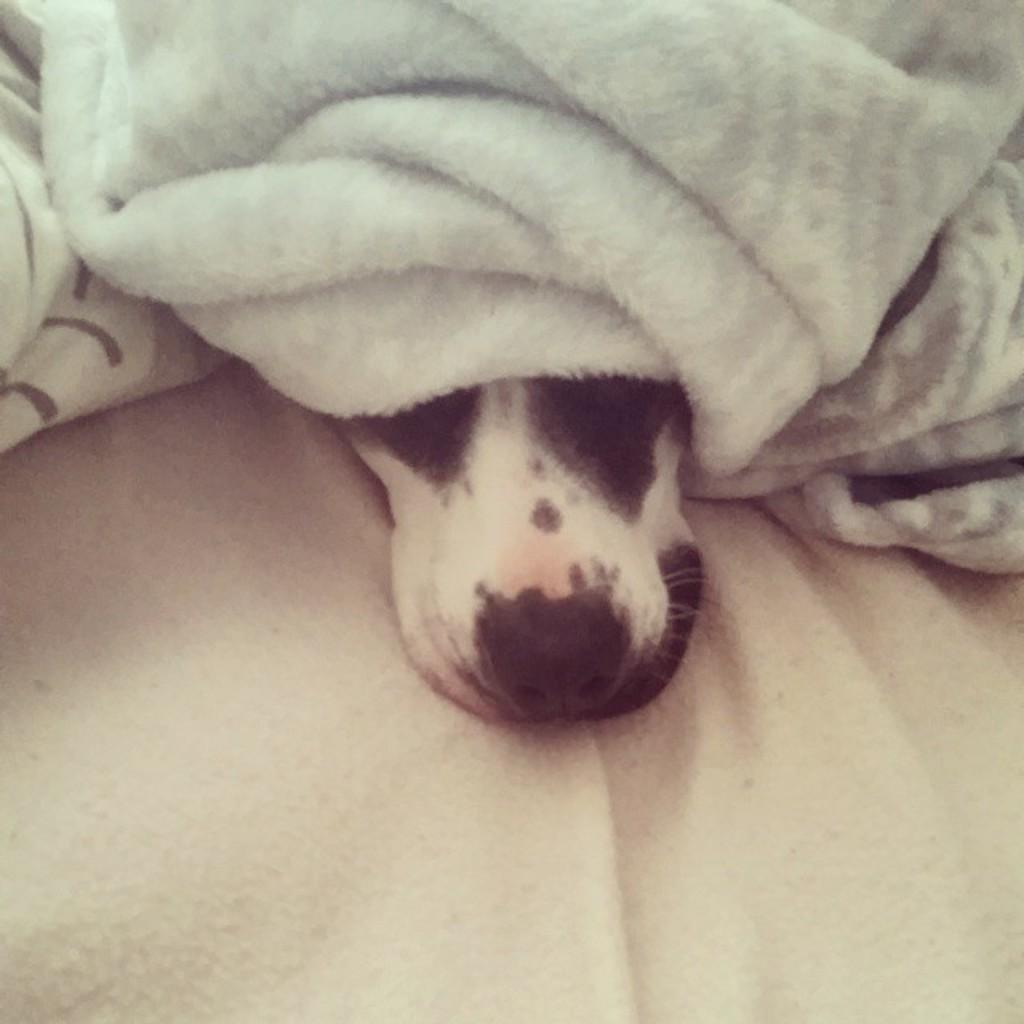What type of animal is in the image? There is a dog in the image. What colors can be seen on the dog's fur? The dog has white and black coloring. What is the dog sitting on in the image? The dog is on a white cloth. What is covering the dog in the image? There is a blanket on the dog. What type of pipe is the dog playing with in the image? There is no pipe present in the image; the dog is simply sitting on a white cloth with a blanket on it. 